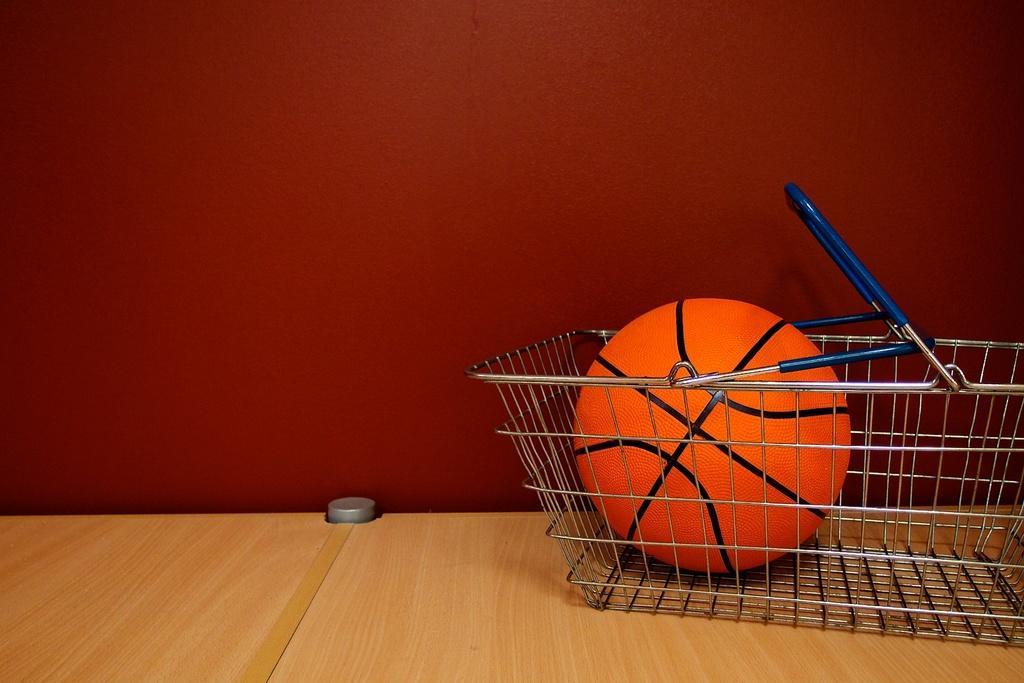In one or two sentences, can you explain what this image depicts? In this image, we can see an orange ball with black lines in the basket. This basket is placed on the wooden surface. Background there is a maroon wall. Here we can see a silver color rod. 